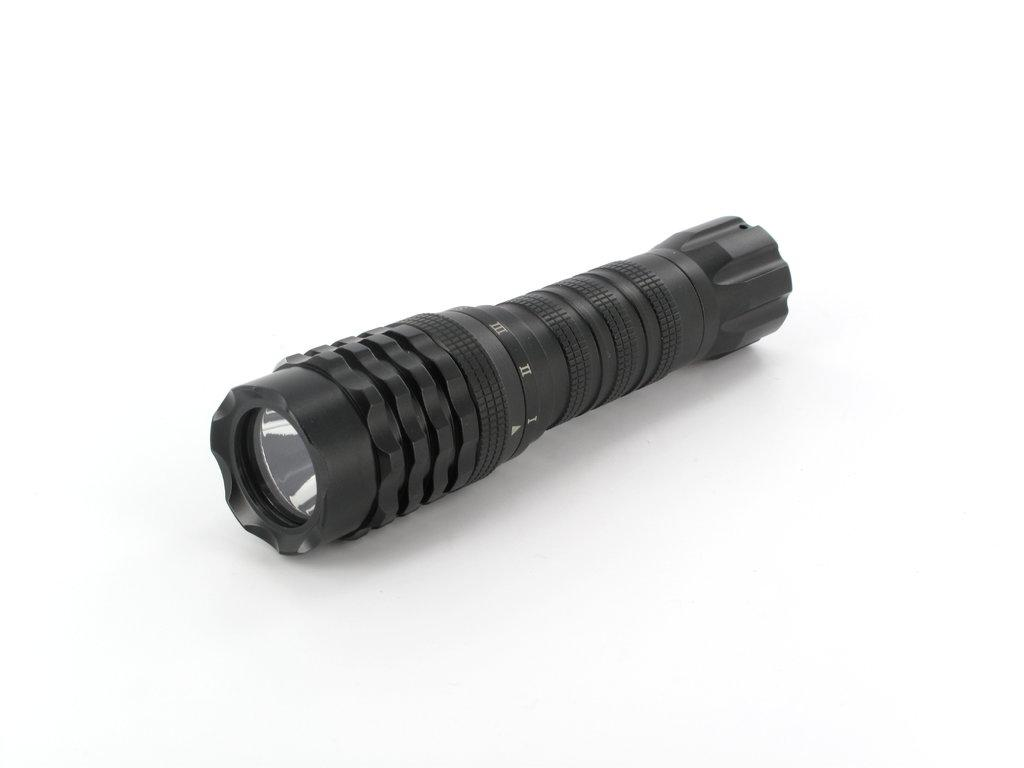What type of light is present in the image? There is a touch light in the image. How might the touch light be activated? The touch light might be activated by touching the surface of the light. What is the primary function of the touch light? The primary function of the touch light is to provide illumination. How many visitors are present in the image? There are no visitors present in the image; it only features a touch light. What type of rat can be seen interacting with the touch light in the image? There are no rats present in the image; it only features a touch light. 